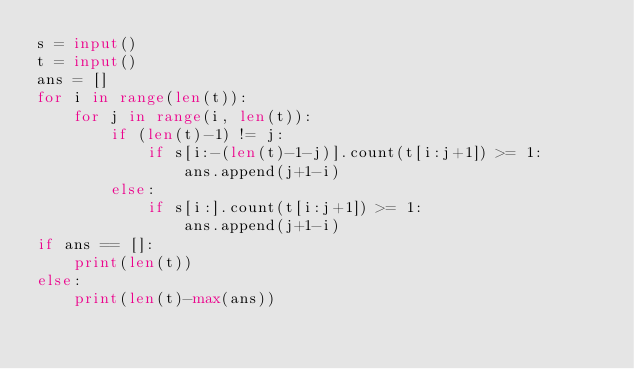Convert code to text. <code><loc_0><loc_0><loc_500><loc_500><_Python_>s = input()
t = input()
ans = []
for i in range(len(t)):
    for j in range(i, len(t)):
        if (len(t)-1) != j:
            if s[i:-(len(t)-1-j)].count(t[i:j+1]) >= 1:
                ans.append(j+1-i)
        else:
            if s[i:].count(t[i:j+1]) >= 1:
                ans.append(j+1-i)
if ans == []:
    print(len(t))
else:
    print(len(t)-max(ans))</code> 